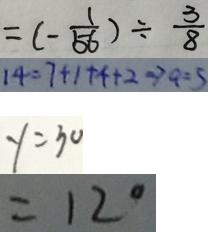Convert formula to latex. <formula><loc_0><loc_0><loc_500><loc_500>= ( - \frac { 1 } { 5 6 } ) \div \frac { 3 } { 8 } 
 1 4 = 7 + 1 + 4 + 2 \Rightarrow a = 5 
 y = 3 0 
 = 1 2 ^ { \circ }</formula> 